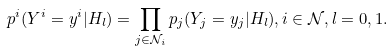<formula> <loc_0><loc_0><loc_500><loc_500>p ^ { i } ( Y ^ { i } = y ^ { i } | H _ { l } ) = \prod _ { j \in \mathcal { N } _ { i } } p _ { j } ( Y _ { j } = y _ { j } | H _ { l } ) , i \in \mathcal { N } , l = 0 , 1 .</formula> 